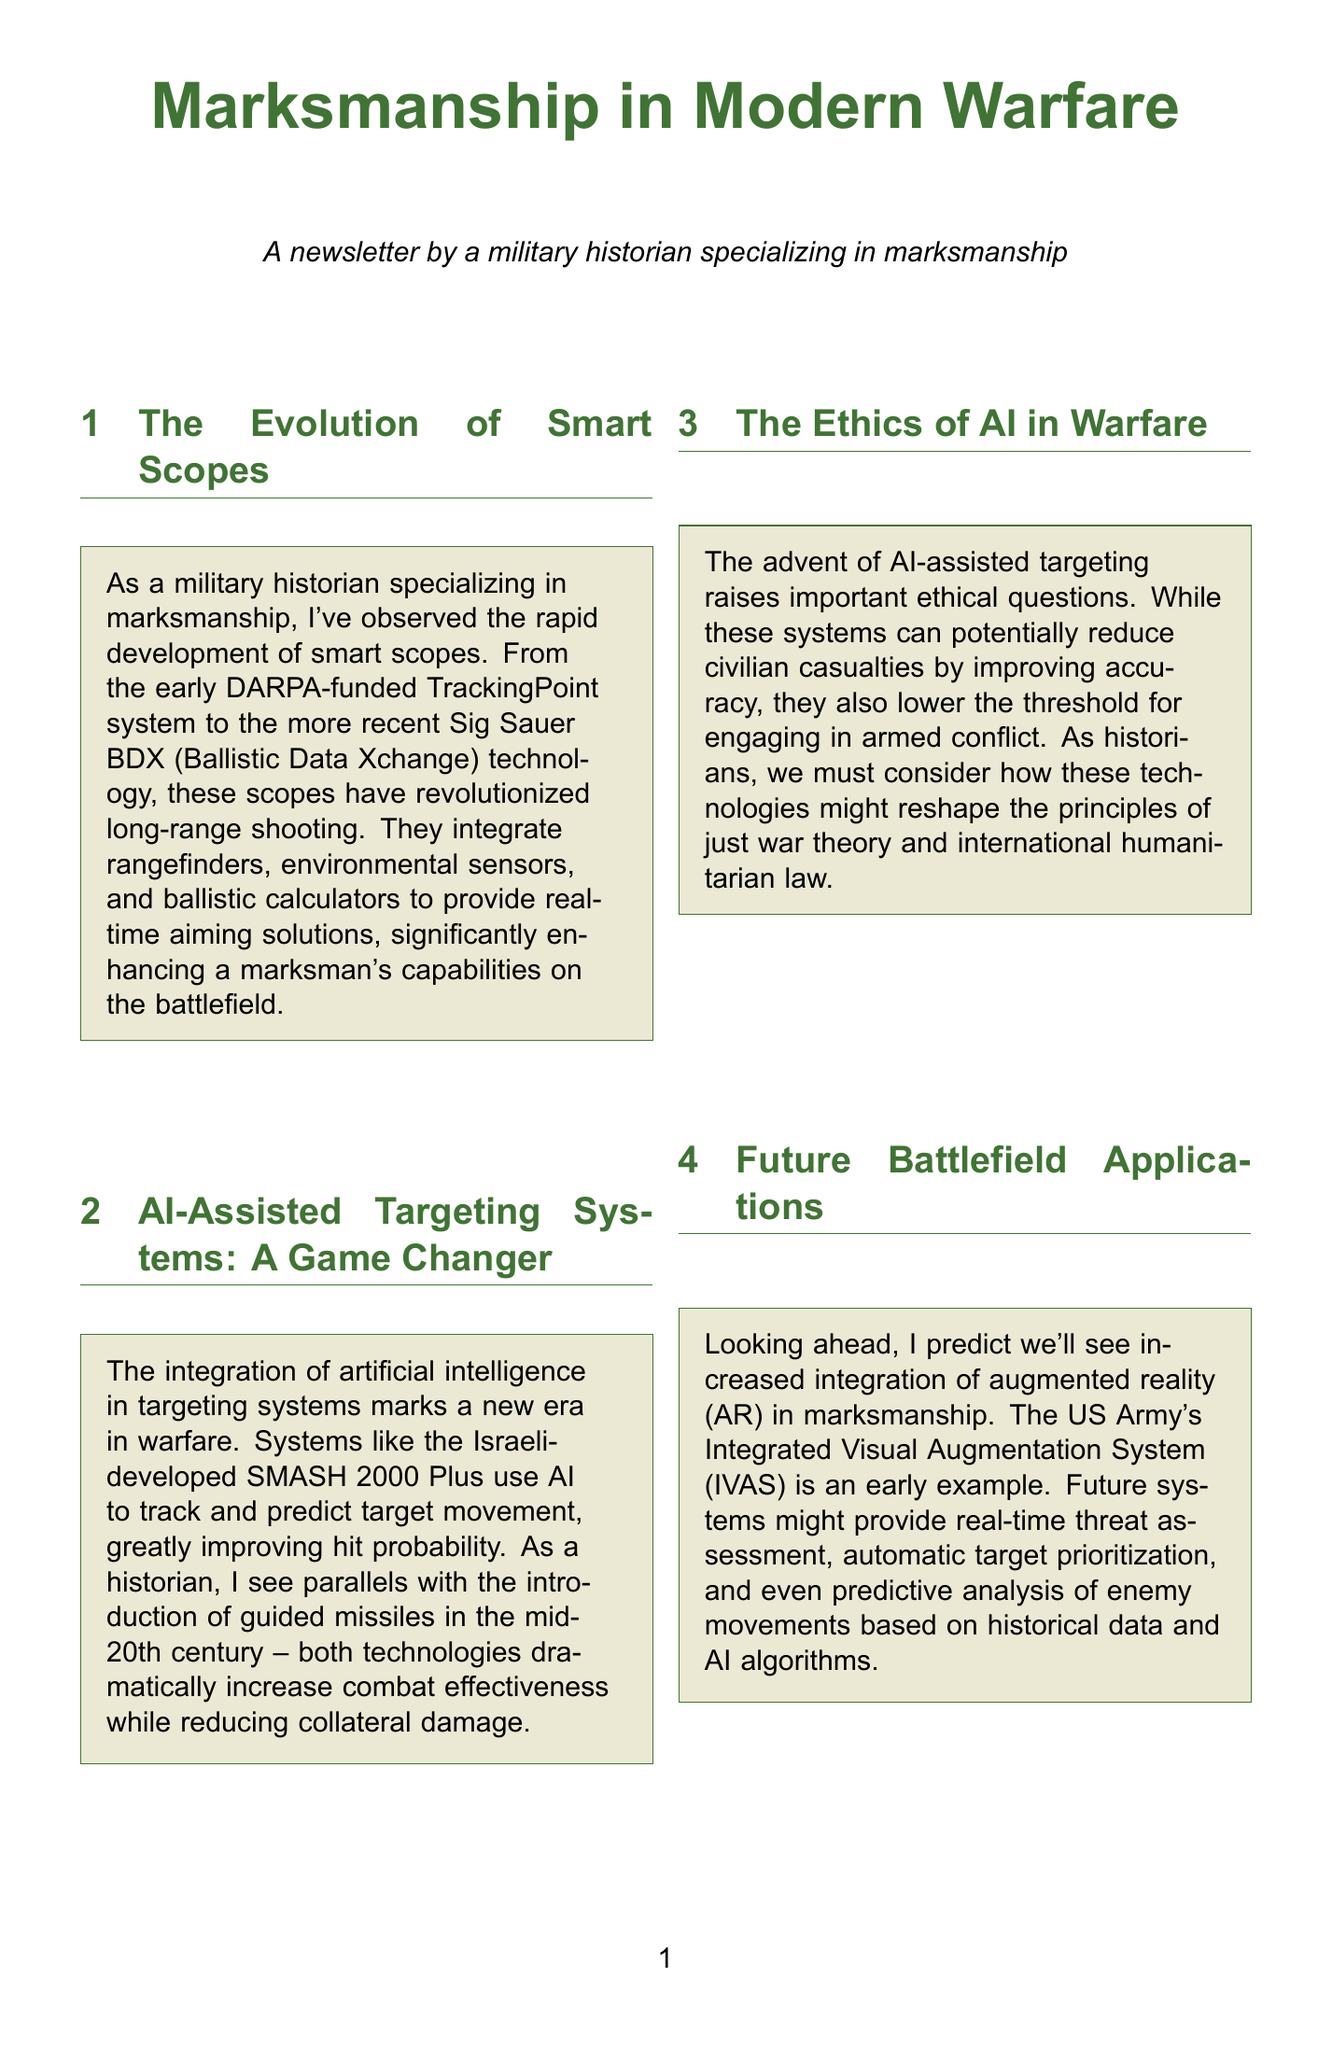What technology revolutionized long-range shooting? The document mentions that smart scopes have revolutionized long-range shooting, integrating various components for improved performance.
Answer: Smart scopes What system uses AI to track target movement? The document refers to the Israeli-developed SMASH 2000 Plus as a system that utilizes AI for tracking and predicting target movement.
Answer: SMASH 2000 Plus What ethical concern is raised by AI-assisted targeting? The content discusses the ethical implications regarding the increased likelihood of engaging in armed conflict due to AI systems.
Answer: Lower threshold for engaging in armed conflict What future technology integration is predicted for marksmanship? The document predicts that augmented reality (AR) will see increased integration in marksmanship practices on the battlefield.
Answer: Augmented reality What training system is mentioned that is currently used? The document mentions the Meggitt FATS 100MIL as a virtual and augmented reality system used for training marksmen.
Answer: Meggitt FATS 100MIL In which historical context is the importance of human skill emphasized? The author compares the advancement of technology in warfare to the longbow's effectiveness in medieval times, emphasizing the need for human skill.
Answer: Longbow's dominance in medieval warfare What will future training programs potentially use to improve marksmen? The document suggests that future training could involve AI-powered adaptive training programs for real-time feedback on shooters' weaknesses.
Answer: AI-powered adaptive training programs Which army is mentioned as having an early example of AR integration? The document specifically mentions the US Army in the context of augmented reality systems.
Answer: US Army 